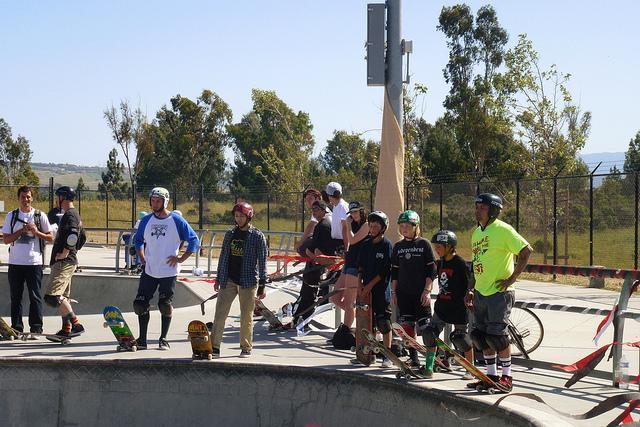How many people are in the picture?
Give a very brief answer. 8. 